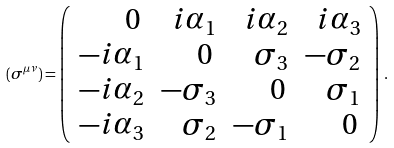<formula> <loc_0><loc_0><loc_500><loc_500>( \sigma ^ { \mu \nu } ) = \left ( \begin{array} { r r r r } 0 \, & i \alpha _ { 1 } & i \alpha _ { 2 } & i \alpha _ { 3 } \\ - i \alpha _ { 1 } & 0 \, & \sigma _ { 3 } & - \sigma _ { 2 } \\ - i \alpha _ { 2 } & - \sigma _ { 3 } & 0 \, & \sigma _ { 1 } \\ - i \alpha _ { 3 } & \sigma _ { 2 } & - \sigma _ { 1 } & 0 \, \end{array} \right ) \, .</formula> 